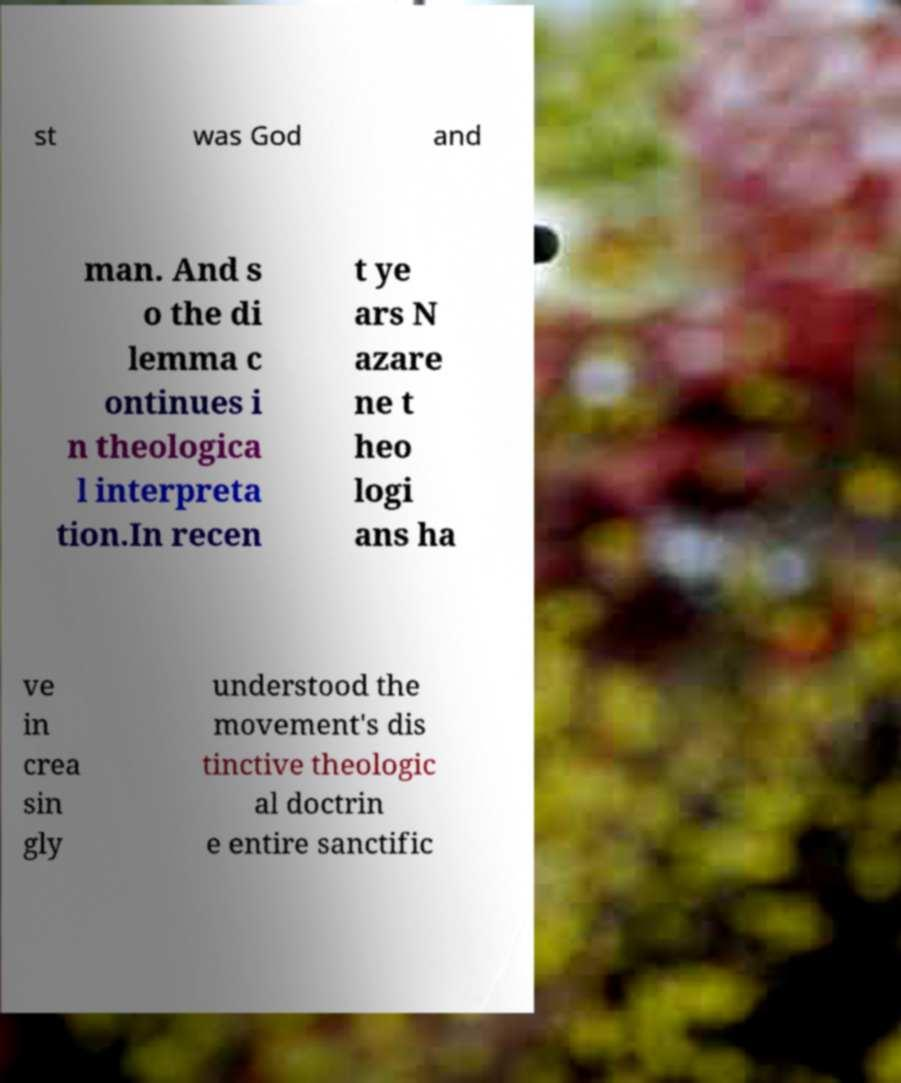Can you read and provide the text displayed in the image?This photo seems to have some interesting text. Can you extract and type it out for me? st was God and man. And s o the di lemma c ontinues i n theologica l interpreta tion.In recen t ye ars N azare ne t heo logi ans ha ve in crea sin gly understood the movement's dis tinctive theologic al doctrin e entire sanctific 